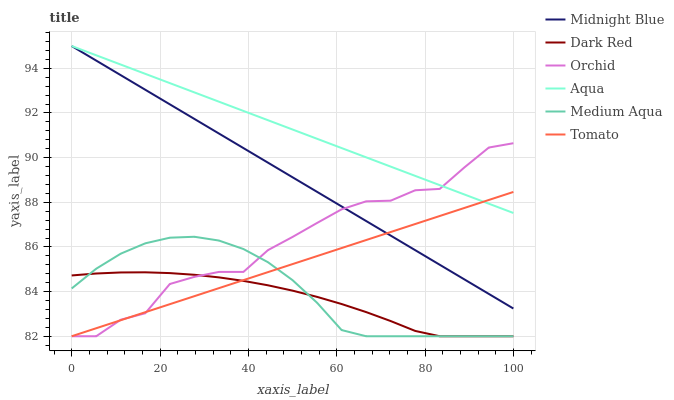Does Dark Red have the minimum area under the curve?
Answer yes or no. Yes. Does Aqua have the maximum area under the curve?
Answer yes or no. Yes. Does Midnight Blue have the minimum area under the curve?
Answer yes or no. No. Does Midnight Blue have the maximum area under the curve?
Answer yes or no. No. Is Tomato the smoothest?
Answer yes or no. Yes. Is Orchid the roughest?
Answer yes or no. Yes. Is Midnight Blue the smoothest?
Answer yes or no. No. Is Midnight Blue the roughest?
Answer yes or no. No. Does Tomato have the lowest value?
Answer yes or no. Yes. Does Midnight Blue have the lowest value?
Answer yes or no. No. Does Aqua have the highest value?
Answer yes or no. Yes. Does Dark Red have the highest value?
Answer yes or no. No. Is Medium Aqua less than Aqua?
Answer yes or no. Yes. Is Midnight Blue greater than Dark Red?
Answer yes or no. Yes. Does Tomato intersect Midnight Blue?
Answer yes or no. Yes. Is Tomato less than Midnight Blue?
Answer yes or no. No. Is Tomato greater than Midnight Blue?
Answer yes or no. No. Does Medium Aqua intersect Aqua?
Answer yes or no. No. 